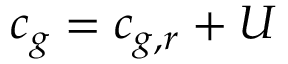<formula> <loc_0><loc_0><loc_500><loc_500>c _ { g } = c _ { g , r } + U</formula> 